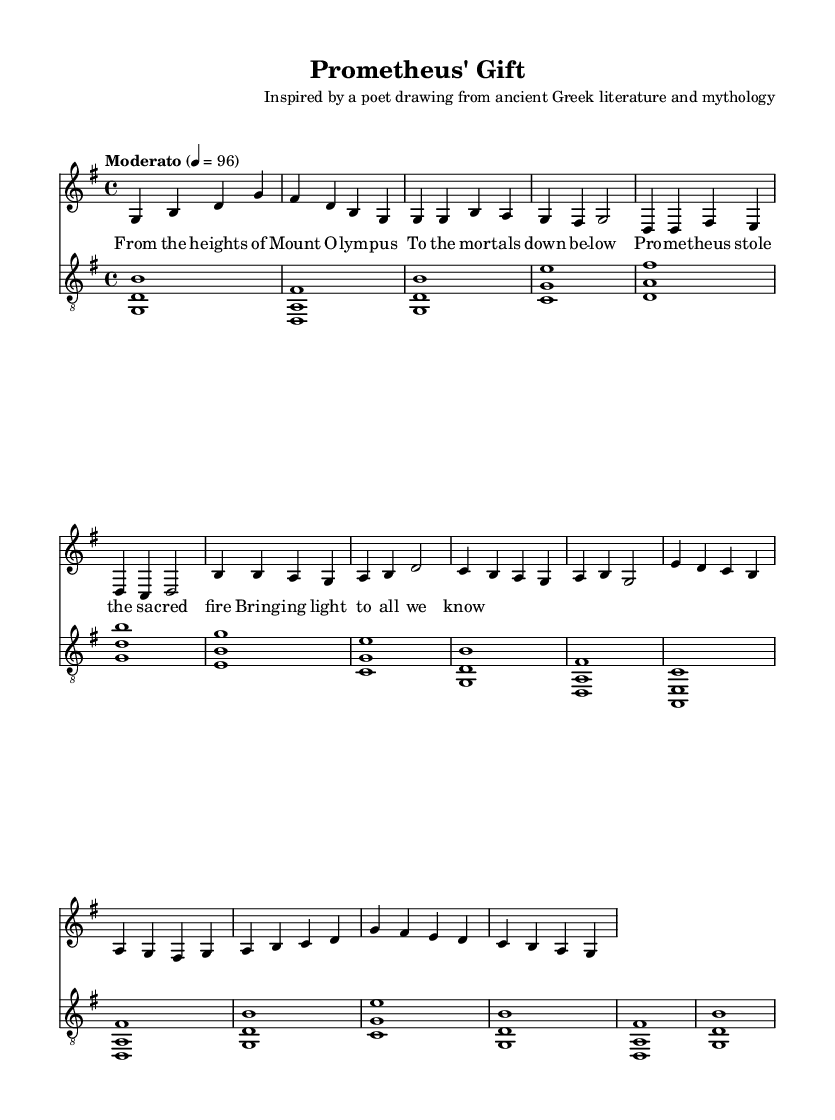What is the key signature of this music? The key signature is G major, which contains one sharp (F#). This can be determined by looking at the key signature marking at the beginning of the staff.
Answer: G major What is the time signature of this music? The time signature is 4/4, which indicates four beats in a measure and a quarter note receives one beat. This is observable at the beginning of the sheet music where the time signature is displayed.
Answer: 4/4 What is the tempo marking? The tempo marking is "Moderato" at a speed of 96 beats per minute. This is specified at the beginning of the score, indicating the pace at which the piece should be performed.
Answer: Moderato 4 = 96 What is the first word of the verse? The first word of the verse is "From", which can be found in the lyrics section under the verseWords variable.
Answer: From What are the main themes expressed in the chorus? The main themes expressed in the chorus include the act of Prometheus stealing sacred fire and bringing light to mortals, reflecting both a mythological narrative and a spiritual significance. This can be inferred from the lyrics presented in the chorusWords section.
Answer: Sacred fire, light How many measures are there in the chorus? The chorus contains four measures as indicated by the grouping of notes and bar lines. This can be counted directly from the corresponding section in the sheet music.
Answer: 4 What is the significance of Prometheus in this song? Prometheus is significant in this song as he represents the bringer of knowledge and enlightenment to humanity, embodied in the act of stealing fire. This narrative choice reflects the spiritual undertones of the song, connecting mythology with deeper religious themes. This understanding comes from analyzing the lyrical content and its implications.
Answer: Knowledge, enlightenment 